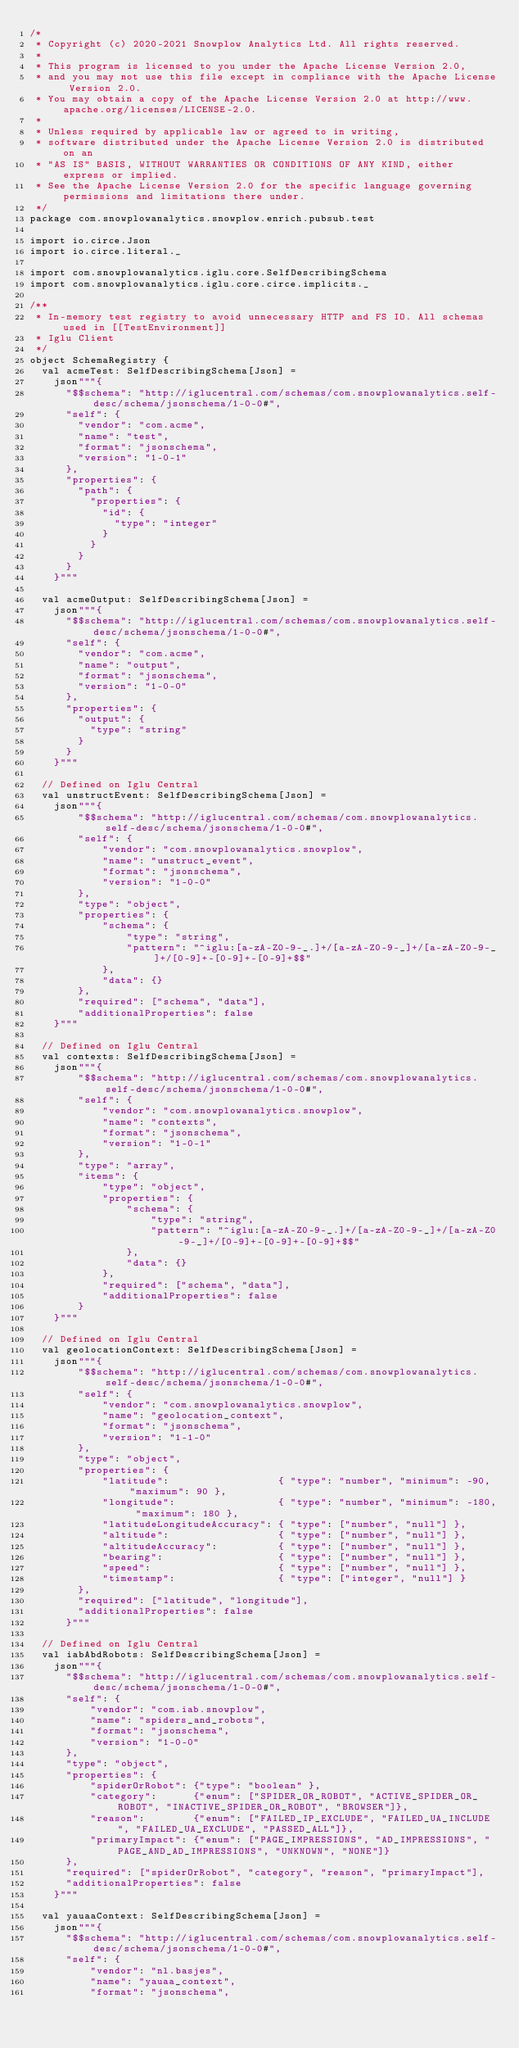Convert code to text. <code><loc_0><loc_0><loc_500><loc_500><_Scala_>/*
 * Copyright (c) 2020-2021 Snowplow Analytics Ltd. All rights reserved.
 *
 * This program is licensed to you under the Apache License Version 2.0,
 * and you may not use this file except in compliance with the Apache License Version 2.0.
 * You may obtain a copy of the Apache License Version 2.0 at http://www.apache.org/licenses/LICENSE-2.0.
 *
 * Unless required by applicable law or agreed to in writing,
 * software distributed under the Apache License Version 2.0 is distributed on an
 * "AS IS" BASIS, WITHOUT WARRANTIES OR CONDITIONS OF ANY KIND, either express or implied.
 * See the Apache License Version 2.0 for the specific language governing permissions and limitations there under.
 */
package com.snowplowanalytics.snowplow.enrich.pubsub.test

import io.circe.Json
import io.circe.literal._

import com.snowplowanalytics.iglu.core.SelfDescribingSchema
import com.snowplowanalytics.iglu.core.circe.implicits._

/**
 * In-memory test registry to avoid unnecessary HTTP and FS IO. All schemas used in [[TestEnvironment]]
 * Iglu Client
 */
object SchemaRegistry {
  val acmeTest: SelfDescribingSchema[Json] =
    json"""{
      "$$schema": "http://iglucentral.com/schemas/com.snowplowanalytics.self-desc/schema/jsonschema/1-0-0#",
      "self": {
        "vendor": "com.acme",
        "name": "test",
        "format": "jsonschema",
        "version": "1-0-1"
      },
      "properties": {
        "path": {
          "properties": {
            "id": {
              "type": "integer"
            }
          }
        }
      }
    }"""

  val acmeOutput: SelfDescribingSchema[Json] =
    json"""{
      "$$schema": "http://iglucentral.com/schemas/com.snowplowanalytics.self-desc/schema/jsonschema/1-0-0#",
      "self": {
        "vendor": "com.acme",
        "name": "output",
        "format": "jsonschema",
        "version": "1-0-0"
      },
      "properties": {
        "output": {
          "type": "string"
        }
      }
    }"""

  // Defined on Iglu Central
  val unstructEvent: SelfDescribingSchema[Json] =
    json"""{
	    "$$schema": "http://iglucentral.com/schemas/com.snowplowanalytics.self-desc/schema/jsonschema/1-0-0#",
	    "self": {
		    "vendor": "com.snowplowanalytics.snowplow",
		    "name": "unstruct_event",
		    "format": "jsonschema",
		    "version": "1-0-0"
	    },
	    "type": "object",
	    "properties": {
	    	"schema": {
	    		"type": "string",
	    		"pattern": "^iglu:[a-zA-Z0-9-_.]+/[a-zA-Z0-9-_]+/[a-zA-Z0-9-_]+/[0-9]+-[0-9]+-[0-9]+$$"
	    	},
	    	"data": {}
	    },
	    "required": ["schema", "data"],
	    "additionalProperties": false
    }"""

  // Defined on Iglu Central
  val contexts: SelfDescribingSchema[Json] =
    json"""{
	    "$$schema": "http://iglucentral.com/schemas/com.snowplowanalytics.self-desc/schema/jsonschema/1-0-0#",
	    "self": {
	    	"vendor": "com.snowplowanalytics.snowplow",
	    	"name": "contexts",
	    	"format": "jsonschema",
	    	"version": "1-0-1"
	    },
	    "type": "array",
	    "items": {
	    	"type": "object",
	    	"properties": {
	    		"schema": {
	    			"type": "string",
	    			"pattern": "^iglu:[a-zA-Z0-9-_.]+/[a-zA-Z0-9-_]+/[a-zA-Z0-9-_]+/[0-9]+-[0-9]+-[0-9]+$$"
	    		},
	    		"data": {}
	    	},
	    	"required": ["schema", "data"],
	    	"additionalProperties": false
	    }
    }"""

  // Defined on Iglu Central
  val geolocationContext: SelfDescribingSchema[Json] =
    json"""{
      	"$$schema": "http://iglucentral.com/schemas/com.snowplowanalytics.self-desc/schema/jsonschema/1-0-0#",
      	"self": {
      		"vendor": "com.snowplowanalytics.snowplow",
      		"name": "geolocation_context",
      		"format": "jsonschema",
      		"version": "1-1-0"
      	},
      	"type": "object",
      	"properties": {
      		"latitude":                  { "type": "number", "minimum": -90, "maximum": 90 },
      		"longitude":                 { "type": "number", "minimum": -180, "maximum": 180 },
      		"latitudeLongitudeAccuracy": { "type": ["number", "null"] },
      		"altitude":                  { "type": ["number", "null"] },
      		"altitudeAccuracy":          { "type": ["number", "null"] },
      		"bearing":                   { "type": ["number", "null"] },
      		"speed":                     { "type": ["number", "null"] },
      		"timestamp":                 { "type": ["integer", "null"] }
      	},
      	"required": ["latitude", "longitude"],
      	"additionalProperties": false
      }"""

  // Defined on Iglu Central
  val iabAbdRobots: SelfDescribingSchema[Json] =
    json"""{
      "$$schema": "http://iglucentral.com/schemas/com.snowplowanalytics.self-desc/schema/jsonschema/1-0-0#",
      "self": {
          "vendor": "com.iab.snowplow",
          "name": "spiders_and_robots",
          "format": "jsonschema",
          "version": "1-0-0"
      },
      "type": "object",
      "properties": {
          "spiderOrRobot": {"type": "boolean" },
          "category":      {"enum": ["SPIDER_OR_ROBOT", "ACTIVE_SPIDER_OR_ROBOT", "INACTIVE_SPIDER_OR_ROBOT", "BROWSER"]},
          "reason":        {"enum": ["FAILED_IP_EXCLUDE", "FAILED_UA_INCLUDE", "FAILED_UA_EXCLUDE", "PASSED_ALL"]},
          "primaryImpact": {"enum": ["PAGE_IMPRESSIONS", "AD_IMPRESSIONS", "PAGE_AND_AD_IMPRESSIONS", "UNKNOWN", "NONE"]}
      },
      "required": ["spiderOrRobot", "category", "reason", "primaryImpact"],
      "additionalProperties": false
    }"""

  val yauaaContext: SelfDescribingSchema[Json] =
    json"""{
      "$$schema": "http://iglucentral.com/schemas/com.snowplowanalytics.self-desc/schema/jsonschema/1-0-0#",
      "self": {
          "vendor": "nl.basjes",
          "name": "yauaa_context",
          "format": "jsonschema",</code> 